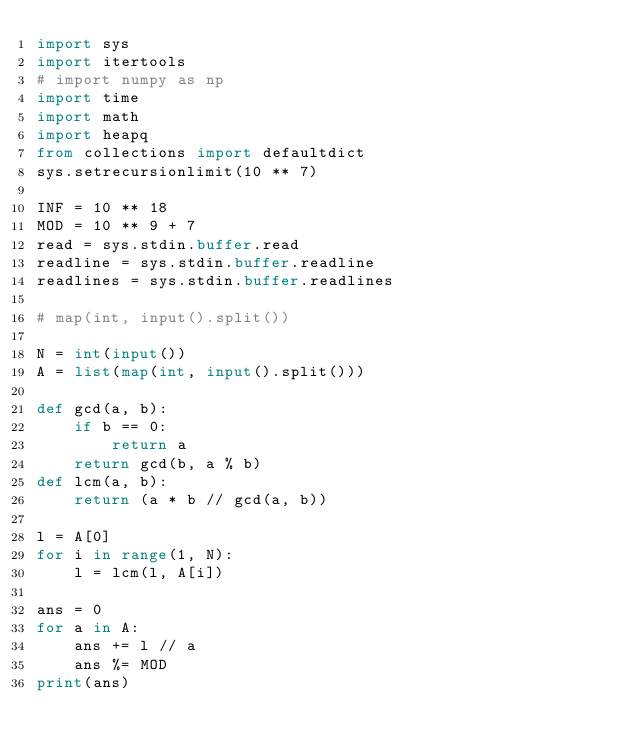<code> <loc_0><loc_0><loc_500><loc_500><_Python_>import sys
import itertools
# import numpy as np
import time
import math
import heapq
from collections import defaultdict
sys.setrecursionlimit(10 ** 7)
 
INF = 10 ** 18
MOD = 10 ** 9 + 7
read = sys.stdin.buffer.read
readline = sys.stdin.buffer.readline
readlines = sys.stdin.buffer.readlines

# map(int, input().split())

N = int(input())
A = list(map(int, input().split()))

def gcd(a, b):
    if b == 0:
        return a
    return gcd(b, a % b)
def lcm(a, b):
    return (a * b // gcd(a, b))

l = A[0]
for i in range(1, N):
    l = lcm(l, A[i])

ans = 0
for a in A:
    ans += l // a
    ans %= MOD
print(ans)</code> 